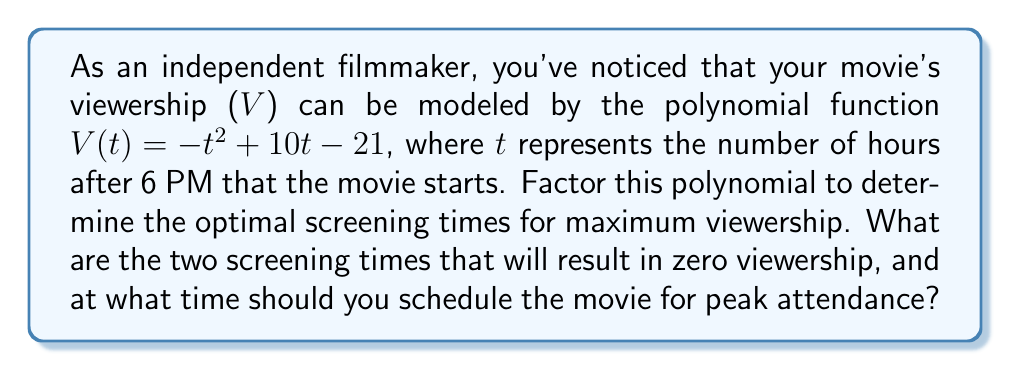What is the answer to this math problem? To solve this problem, we need to factor the given polynomial and analyze its properties:

1) The polynomial is $V(t) = -t^2 + 10t - 21$

2) This is a quadratic equation in the form $ax^2 + bx + c$, where:
   $a = -1$, $b = 10$, and $c = -21$

3) To factor this, we're looking for two numbers that multiply to give $ac = (-1)(-21) = 21$ and add up to $b = 10$

4) These numbers are 7 and 3

5) We can rewrite the polynomial as:
   $V(t) = -t^2 + 7t + 3t - 21$

6) Grouping these terms:
   $V(t) = (-t^2 + 7t) + (3t - 21)$
   $V(t) = -t(t - 7) + 3(t - 7)$
   $V(t) = (t - 7)(-t + 3)$
   $V(t) = -(t - 7)(t - 3)$

7) The factored form shows that $V(t) = 0$ when $t = 7$ or $t = 3$

8) Remember that t represents hours after 6 PM. So:
   - Zero viewership occurs at 6 PM + 3 hours = 9 PM
   - Zero viewership also occurs at 6 PM + 7 hours = 1 AM

9) For the peak attendance, we need to find the vertex of the parabola. In a quadratic equation $-at^2 + bt + c$, the t-coordinate of the vertex is given by $\frac{b}{2a}$

10) In this case, $\frac{b}{2a} = \frac{10}{2(-1)} = -5$

11) Therefore, the peak occurs at $t = 5$, which translates to 6 PM + 5 hours = 11 PM
Answer: Zero viewership occurs at 9 PM and 1 AM. The optimal screening time for peak attendance is 11 PM. 